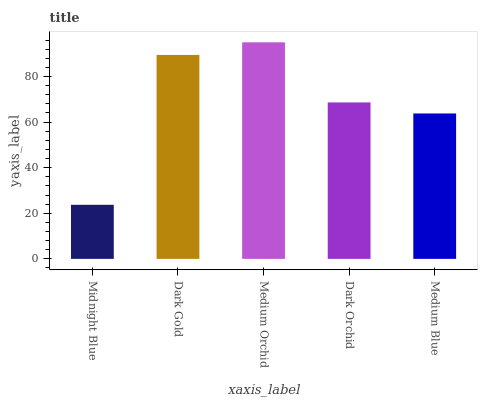Is Midnight Blue the minimum?
Answer yes or no. Yes. Is Medium Orchid the maximum?
Answer yes or no. Yes. Is Dark Gold the minimum?
Answer yes or no. No. Is Dark Gold the maximum?
Answer yes or no. No. Is Dark Gold greater than Midnight Blue?
Answer yes or no. Yes. Is Midnight Blue less than Dark Gold?
Answer yes or no. Yes. Is Midnight Blue greater than Dark Gold?
Answer yes or no. No. Is Dark Gold less than Midnight Blue?
Answer yes or no. No. Is Dark Orchid the high median?
Answer yes or no. Yes. Is Dark Orchid the low median?
Answer yes or no. Yes. Is Midnight Blue the high median?
Answer yes or no. No. Is Dark Gold the low median?
Answer yes or no. No. 